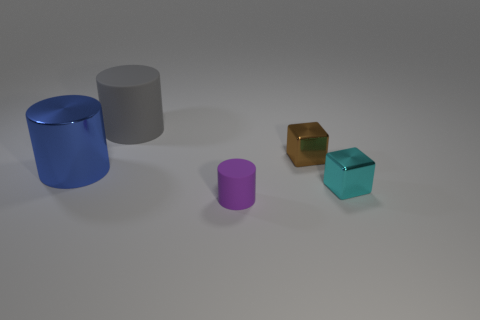There is a cylinder that is the same size as the brown shiny thing; what color is it?
Your answer should be compact. Purple. What size is the shiny thing that is right of the gray thing and on the left side of the tiny cyan metallic block?
Keep it short and to the point. Small. The purple matte thing that is the same shape as the big blue thing is what size?
Your answer should be very brief. Small. What number of things are cubes behind the large metallic cylinder or gray rubber cylinders?
Provide a short and direct response. 2. There is a metal thing that is the same shape as the gray rubber object; what color is it?
Your response must be concise. Blue. Does the small brown object have the same shape as the cyan metal object that is right of the small purple rubber cylinder?
Give a very brief answer. Yes. How many objects are either matte cylinders behind the small purple matte cylinder or cylinders on the left side of the big rubber object?
Ensure brevity in your answer.  2. Is the number of tiny purple cylinders in front of the tiny cylinder less than the number of cylinders?
Provide a short and direct response. Yes. Are the blue object and the cylinder in front of the small cyan metallic thing made of the same material?
Offer a terse response. No. What material is the gray object?
Offer a terse response. Rubber. 